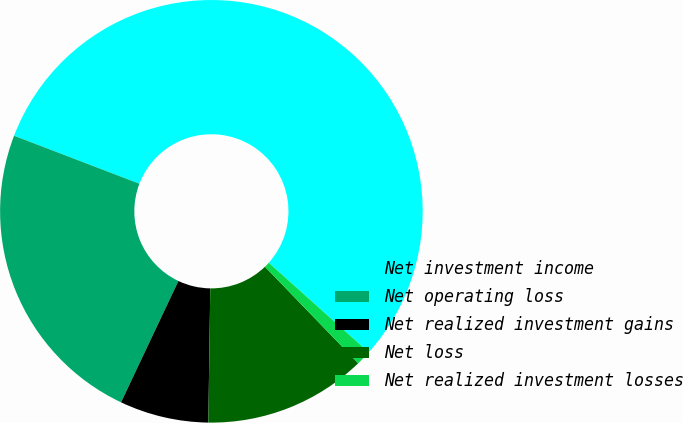Convert chart. <chart><loc_0><loc_0><loc_500><loc_500><pie_chart><fcel>Net investment income<fcel>Net operating loss<fcel>Net realized investment gains<fcel>Net loss<fcel>Net realized investment losses<nl><fcel>55.81%<fcel>23.79%<fcel>6.8%<fcel>12.46%<fcel>1.14%<nl></chart> 